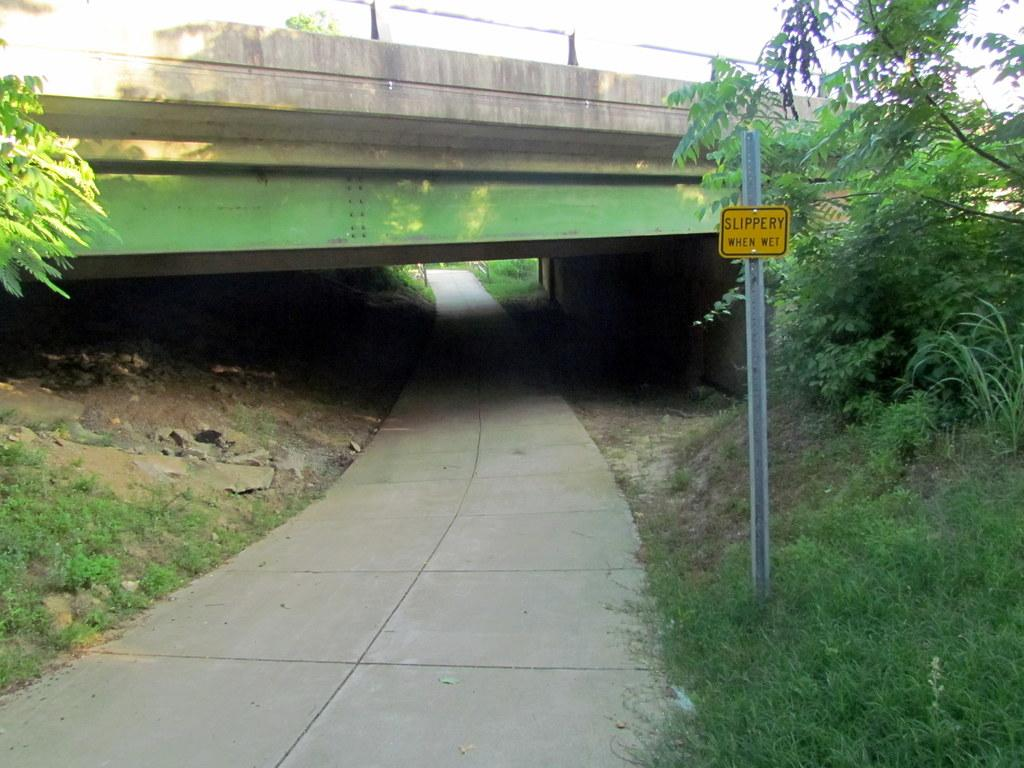What type of pathway is visible in the image? There is a road in the image. What natural elements can be seen in the image? There are trees and grass in the image. What type of structure is present in the image? There is a bridge in the image. What is attached to the pole in the image? There is a board attached to the pole in the image. What is visible in the background of the image? The sky is visible in the background of the image. Can you see any quicksand on the road in the image? There is no quicksand present in the image. Is the person's brother visible in the image? There is no person or brother mentioned in the image; it only contains a road, trees, grass, a bridge, a pole with a board, and the sky. 